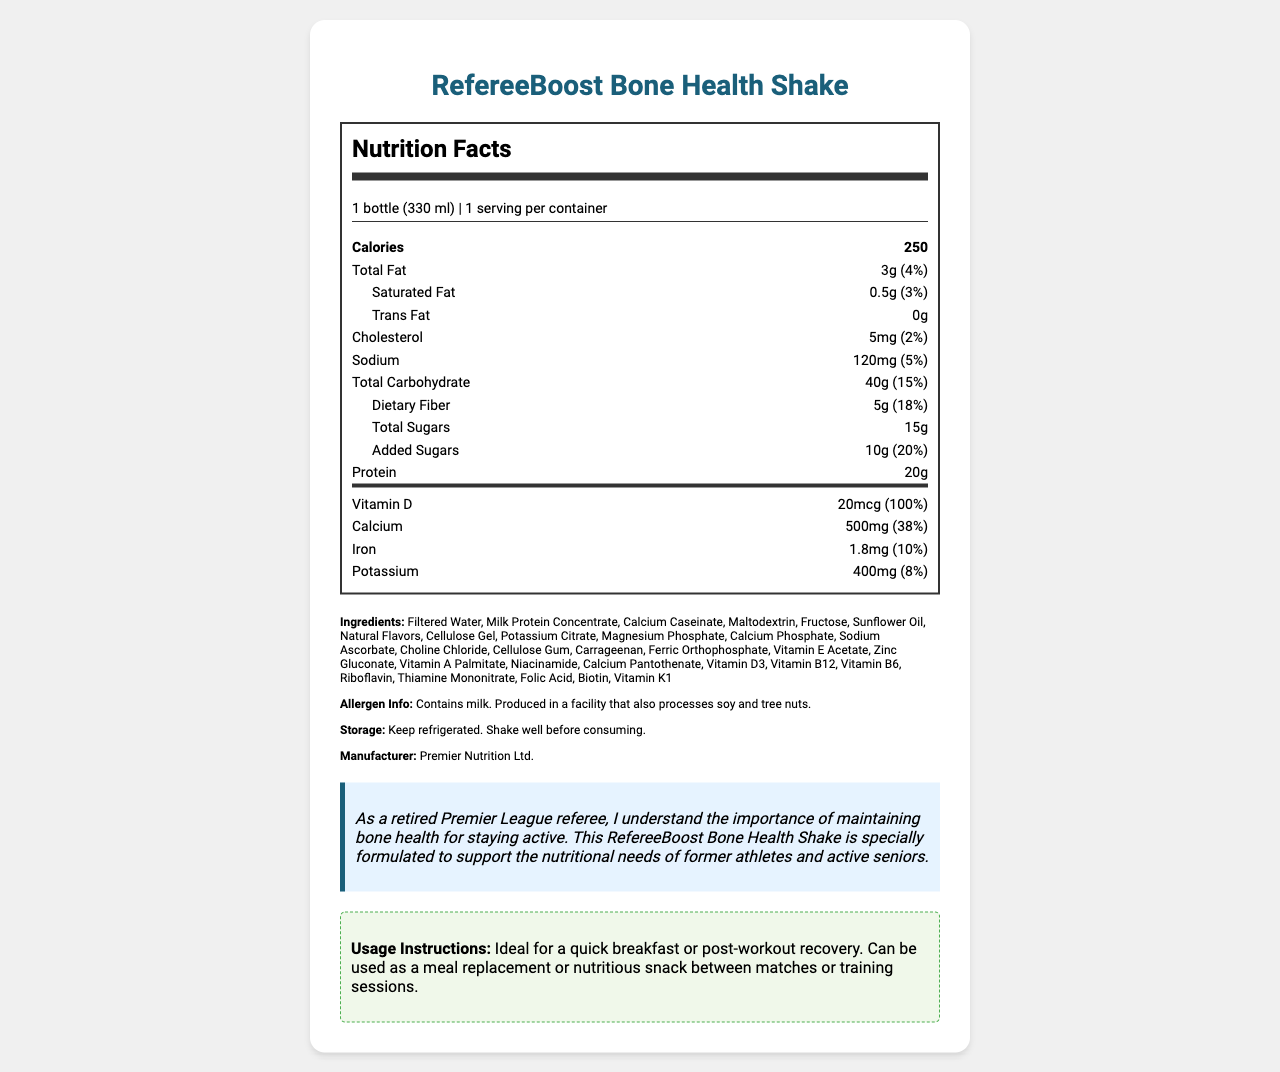what is the serving size of the RefereeBoost Bone Health Shake? The serving size is explicitly mentioned as "1 bottle (330 ml)" in the document.
Answer: 1 bottle (330 ml) how many calories are in one serving of the RefereeBoost Bone Health Shake? The document lists the total calories per serving as 250.
Answer: 250 calories what percentage of the daily value of vitamin D does the shake provide? The document shows that the shake provides 20mcg of vitamin D, which is 100% of the daily value.
Answer: 100% where should the shake be stored? The document states, "Keep refrigerated" under storage instructions.
Answer: Refrigerated name two main vitamins in the shake and their daily values. The document lists several vitamins, including vitamin D which has a daily value of 100%, and vitamin C with a daily value of 67%.
Answer: Vitamin D (100%), Vitamin C (67%) how much protein is in the shake? The document shows that the protein content is 20 grams per serving.
Answer: 20g what is the total amount of sugars in the shake? The document lists the total sugars as 15 grams.
Answer: 15g what are the main protein sources in the shake? The ingredients list "Milk Protein Concentrate" and "Calcium Caseinate" as sources of protein.
Answer: Milk Protein Concentrate, Calcium Caseinate how much sodium is in one serving, and what is its daily value percentage? The document states that the shake contains 120mg of sodium, which is 5% of the daily value.
Answer: 120mg, 5% what is the total fat content, and what are its main types? The document lists total fat as 3 grams (4% daily value), Saturated Fat as 0.5 grams (3% daily value), and Trans Fat as 0 grams.
Answer: 3g (4% daily value), Saturated Fat: 0.5g (3% daily value), Trans Fat: 0g which of the following vitamins are present in the shake? A. Vitamin B12 B. Vitamin C C. Vitamin K D. All of the above The document lists Vitamin B12, Vitamin C, and Vitamin K amongst the ingredients.
Answer: D. All of the above what is the amount of dietary fiber in the shake? A. 3g B. 4g C. 5g The document lists dietary fiber as 5 grams (18% daily value).
Answer: C. 5g does the product contain any cholesterol? The document lists 5mg of cholesterol, which is 2% of the daily value.
Answer: Yes is the shake suitable for people with nut allergies? The document mentions it is produced in a facility that processes tree nuts, posing a risk for individuals with nut allergies.
Answer: No what are the usage instructions for the shake? The usage instructions are explicitly stated in the document.
Answer: Ideal for a quick breakfast or post-workout recovery. Can be used as a meal replacement or nutritious snack between matches or training sessions. who manufactures the RefereeBoost Bone Health Shake? The manufacturer is stated as Premier Nutrition Ltd. in the document.
Answer: Premier Nutrition Ltd. can you tell me all the ingredients listed? The document contains a comprehensive list of all ingredients used in the shake.
Answer: Filtered Water, Milk Protein Concentrate, Calcium Caseinate, Maltodextrin, Fructose, Sunflower Oil, Natural Flavors, Cellulose Gel, Potassium Citrate, Magnesium Phosphate, Calcium Phosphate, Sodium Ascorbate, Choline Chloride, Cellulose Gum, Carrageenan, Ferric Orthophosphate, Vitamin E Acetate, Zinc Gluconate, Vitamin A Palmitate, Niacinamide, Calcium Pantothenate, Vitamin D3, Vitamin B12, Vitamin B6, Riboflavin, Thiamine Mononitrate, Folic Acid, Biotin, Vitamin K1 summarize the main idea of the document. The document covers various aspects of the RefereeBoost Bone Health Shake including its nutrition facts, ingredients, allergen information, storage, manufacturer, and targeted usage instructions for maintaining bone health in older adults.
Answer: The document provides detailed nutritional information, ingredient list, allergen information, storage instructions, manufacturer details, and usage instructions for the RefereeBoost Bone Health Shake. This shake is specifically designed to support bone health in older adults, especially former athletes, and active seniors. what is the carbohydrate content of the shake per serving? Total carbohydrates are listed as 40 grams per serving.
Answer: 40g how much calcium does the shake contain? The document states the shake contains 500mg of calcium, which is 38% of the daily value.
Answer: 500mg (38% daily value) is the exact formulation used in the shake provided? The document lists ingredients and nutritional values but does not provide the exact formulation or proportions of each ingredient.
Answer: Not enough information 